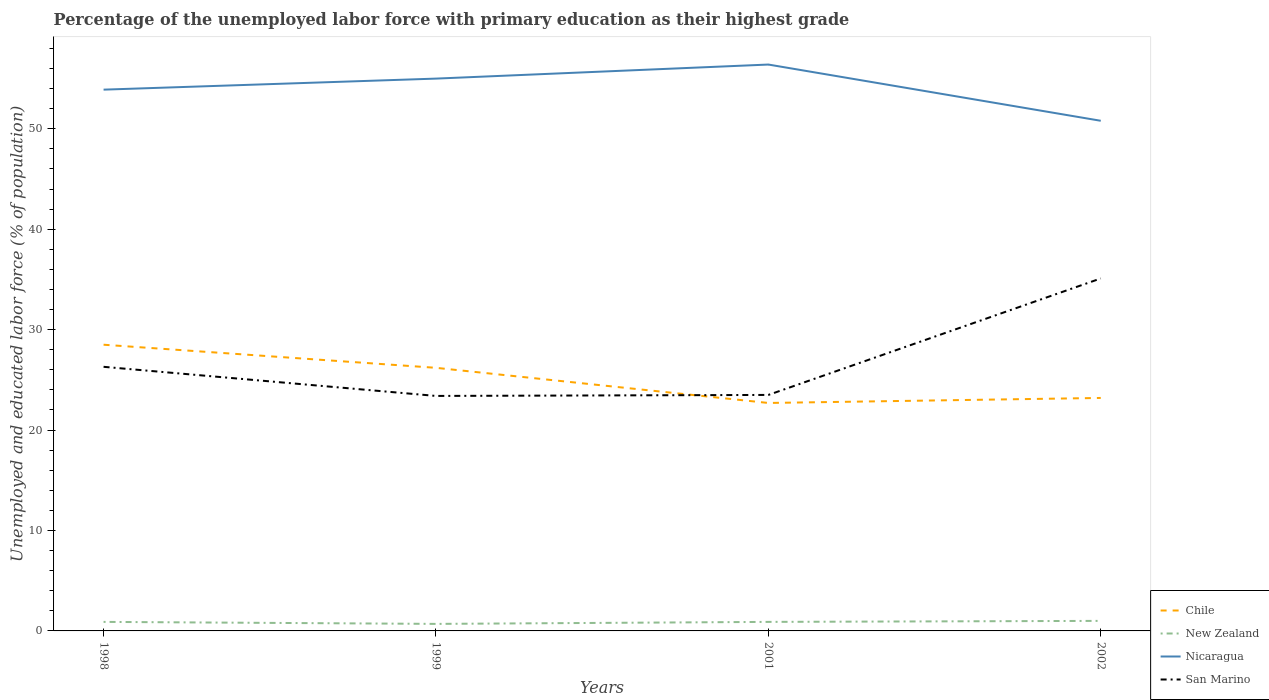Across all years, what is the maximum percentage of the unemployed labor force with primary education in Nicaragua?
Provide a succinct answer. 50.8. What is the total percentage of the unemployed labor force with primary education in Nicaragua in the graph?
Make the answer very short. 5.6. What is the difference between the highest and the second highest percentage of the unemployed labor force with primary education in Chile?
Give a very brief answer. 5.8. How many years are there in the graph?
Provide a short and direct response. 4. How many legend labels are there?
Your answer should be compact. 4. What is the title of the graph?
Offer a very short reply. Percentage of the unemployed labor force with primary education as their highest grade. Does "Bosnia and Herzegovina" appear as one of the legend labels in the graph?
Offer a terse response. No. What is the label or title of the X-axis?
Your answer should be compact. Years. What is the label or title of the Y-axis?
Keep it short and to the point. Unemployed and educated labor force (% of population). What is the Unemployed and educated labor force (% of population) of New Zealand in 1998?
Your answer should be compact. 0.9. What is the Unemployed and educated labor force (% of population) of Nicaragua in 1998?
Make the answer very short. 53.9. What is the Unemployed and educated labor force (% of population) of San Marino in 1998?
Offer a very short reply. 26.3. What is the Unemployed and educated labor force (% of population) of Chile in 1999?
Your answer should be very brief. 26.2. What is the Unemployed and educated labor force (% of population) in New Zealand in 1999?
Offer a very short reply. 0.7. What is the Unemployed and educated labor force (% of population) of San Marino in 1999?
Provide a short and direct response. 23.4. What is the Unemployed and educated labor force (% of population) in Chile in 2001?
Your response must be concise. 22.7. What is the Unemployed and educated labor force (% of population) of New Zealand in 2001?
Keep it short and to the point. 0.9. What is the Unemployed and educated labor force (% of population) in Nicaragua in 2001?
Keep it short and to the point. 56.4. What is the Unemployed and educated labor force (% of population) of San Marino in 2001?
Make the answer very short. 23.5. What is the Unemployed and educated labor force (% of population) in Chile in 2002?
Your response must be concise. 23.2. What is the Unemployed and educated labor force (% of population) in Nicaragua in 2002?
Provide a succinct answer. 50.8. What is the Unemployed and educated labor force (% of population) in San Marino in 2002?
Provide a succinct answer. 35.1. Across all years, what is the maximum Unemployed and educated labor force (% of population) in Chile?
Give a very brief answer. 28.5. Across all years, what is the maximum Unemployed and educated labor force (% of population) in New Zealand?
Provide a short and direct response. 1. Across all years, what is the maximum Unemployed and educated labor force (% of population) in Nicaragua?
Offer a terse response. 56.4. Across all years, what is the maximum Unemployed and educated labor force (% of population) in San Marino?
Ensure brevity in your answer.  35.1. Across all years, what is the minimum Unemployed and educated labor force (% of population) in Chile?
Your response must be concise. 22.7. Across all years, what is the minimum Unemployed and educated labor force (% of population) of New Zealand?
Offer a very short reply. 0.7. Across all years, what is the minimum Unemployed and educated labor force (% of population) of Nicaragua?
Offer a terse response. 50.8. Across all years, what is the minimum Unemployed and educated labor force (% of population) in San Marino?
Ensure brevity in your answer.  23.4. What is the total Unemployed and educated labor force (% of population) in Chile in the graph?
Offer a very short reply. 100.6. What is the total Unemployed and educated labor force (% of population) of Nicaragua in the graph?
Offer a terse response. 216.1. What is the total Unemployed and educated labor force (% of population) in San Marino in the graph?
Provide a short and direct response. 108.3. What is the difference between the Unemployed and educated labor force (% of population) of Chile in 1998 and that in 1999?
Make the answer very short. 2.3. What is the difference between the Unemployed and educated labor force (% of population) of San Marino in 1998 and that in 1999?
Your answer should be compact. 2.9. What is the difference between the Unemployed and educated labor force (% of population) in Nicaragua in 1998 and that in 2001?
Provide a short and direct response. -2.5. What is the difference between the Unemployed and educated labor force (% of population) of New Zealand in 1998 and that in 2002?
Your answer should be compact. -0.1. What is the difference between the Unemployed and educated labor force (% of population) of Nicaragua in 1998 and that in 2002?
Offer a very short reply. 3.1. What is the difference between the Unemployed and educated labor force (% of population) of San Marino in 1998 and that in 2002?
Your answer should be very brief. -8.8. What is the difference between the Unemployed and educated labor force (% of population) of New Zealand in 1999 and that in 2001?
Offer a terse response. -0.2. What is the difference between the Unemployed and educated labor force (% of population) of San Marino in 1999 and that in 2001?
Provide a short and direct response. -0.1. What is the difference between the Unemployed and educated labor force (% of population) of Chile in 1999 and that in 2002?
Give a very brief answer. 3. What is the difference between the Unemployed and educated labor force (% of population) of Nicaragua in 1999 and that in 2002?
Provide a short and direct response. 4.2. What is the difference between the Unemployed and educated labor force (% of population) of Chile in 2001 and that in 2002?
Your answer should be very brief. -0.5. What is the difference between the Unemployed and educated labor force (% of population) of New Zealand in 2001 and that in 2002?
Keep it short and to the point. -0.1. What is the difference between the Unemployed and educated labor force (% of population) of Chile in 1998 and the Unemployed and educated labor force (% of population) of New Zealand in 1999?
Provide a short and direct response. 27.8. What is the difference between the Unemployed and educated labor force (% of population) in Chile in 1998 and the Unemployed and educated labor force (% of population) in Nicaragua in 1999?
Your answer should be very brief. -26.5. What is the difference between the Unemployed and educated labor force (% of population) of Chile in 1998 and the Unemployed and educated labor force (% of population) of San Marino in 1999?
Provide a short and direct response. 5.1. What is the difference between the Unemployed and educated labor force (% of population) of New Zealand in 1998 and the Unemployed and educated labor force (% of population) of Nicaragua in 1999?
Ensure brevity in your answer.  -54.1. What is the difference between the Unemployed and educated labor force (% of population) in New Zealand in 1998 and the Unemployed and educated labor force (% of population) in San Marino in 1999?
Make the answer very short. -22.5. What is the difference between the Unemployed and educated labor force (% of population) in Nicaragua in 1998 and the Unemployed and educated labor force (% of population) in San Marino in 1999?
Give a very brief answer. 30.5. What is the difference between the Unemployed and educated labor force (% of population) of Chile in 1998 and the Unemployed and educated labor force (% of population) of New Zealand in 2001?
Keep it short and to the point. 27.6. What is the difference between the Unemployed and educated labor force (% of population) of Chile in 1998 and the Unemployed and educated labor force (% of population) of Nicaragua in 2001?
Provide a succinct answer. -27.9. What is the difference between the Unemployed and educated labor force (% of population) of Chile in 1998 and the Unemployed and educated labor force (% of population) of San Marino in 2001?
Offer a very short reply. 5. What is the difference between the Unemployed and educated labor force (% of population) in New Zealand in 1998 and the Unemployed and educated labor force (% of population) in Nicaragua in 2001?
Keep it short and to the point. -55.5. What is the difference between the Unemployed and educated labor force (% of population) of New Zealand in 1998 and the Unemployed and educated labor force (% of population) of San Marino in 2001?
Offer a very short reply. -22.6. What is the difference between the Unemployed and educated labor force (% of population) in Nicaragua in 1998 and the Unemployed and educated labor force (% of population) in San Marino in 2001?
Ensure brevity in your answer.  30.4. What is the difference between the Unemployed and educated labor force (% of population) of Chile in 1998 and the Unemployed and educated labor force (% of population) of Nicaragua in 2002?
Your answer should be compact. -22.3. What is the difference between the Unemployed and educated labor force (% of population) in New Zealand in 1998 and the Unemployed and educated labor force (% of population) in Nicaragua in 2002?
Your answer should be very brief. -49.9. What is the difference between the Unemployed and educated labor force (% of population) in New Zealand in 1998 and the Unemployed and educated labor force (% of population) in San Marino in 2002?
Offer a very short reply. -34.2. What is the difference between the Unemployed and educated labor force (% of population) in Nicaragua in 1998 and the Unemployed and educated labor force (% of population) in San Marino in 2002?
Your answer should be compact. 18.8. What is the difference between the Unemployed and educated labor force (% of population) in Chile in 1999 and the Unemployed and educated labor force (% of population) in New Zealand in 2001?
Keep it short and to the point. 25.3. What is the difference between the Unemployed and educated labor force (% of population) of Chile in 1999 and the Unemployed and educated labor force (% of population) of Nicaragua in 2001?
Ensure brevity in your answer.  -30.2. What is the difference between the Unemployed and educated labor force (% of population) of New Zealand in 1999 and the Unemployed and educated labor force (% of population) of Nicaragua in 2001?
Provide a succinct answer. -55.7. What is the difference between the Unemployed and educated labor force (% of population) of New Zealand in 1999 and the Unemployed and educated labor force (% of population) of San Marino in 2001?
Give a very brief answer. -22.8. What is the difference between the Unemployed and educated labor force (% of population) of Nicaragua in 1999 and the Unemployed and educated labor force (% of population) of San Marino in 2001?
Your response must be concise. 31.5. What is the difference between the Unemployed and educated labor force (% of population) in Chile in 1999 and the Unemployed and educated labor force (% of population) in New Zealand in 2002?
Your answer should be very brief. 25.2. What is the difference between the Unemployed and educated labor force (% of population) of Chile in 1999 and the Unemployed and educated labor force (% of population) of Nicaragua in 2002?
Provide a short and direct response. -24.6. What is the difference between the Unemployed and educated labor force (% of population) in Chile in 1999 and the Unemployed and educated labor force (% of population) in San Marino in 2002?
Offer a very short reply. -8.9. What is the difference between the Unemployed and educated labor force (% of population) in New Zealand in 1999 and the Unemployed and educated labor force (% of population) in Nicaragua in 2002?
Your answer should be very brief. -50.1. What is the difference between the Unemployed and educated labor force (% of population) in New Zealand in 1999 and the Unemployed and educated labor force (% of population) in San Marino in 2002?
Provide a succinct answer. -34.4. What is the difference between the Unemployed and educated labor force (% of population) in Nicaragua in 1999 and the Unemployed and educated labor force (% of population) in San Marino in 2002?
Your response must be concise. 19.9. What is the difference between the Unemployed and educated labor force (% of population) of Chile in 2001 and the Unemployed and educated labor force (% of population) of New Zealand in 2002?
Provide a short and direct response. 21.7. What is the difference between the Unemployed and educated labor force (% of population) in Chile in 2001 and the Unemployed and educated labor force (% of population) in Nicaragua in 2002?
Your answer should be very brief. -28.1. What is the difference between the Unemployed and educated labor force (% of population) in Chile in 2001 and the Unemployed and educated labor force (% of population) in San Marino in 2002?
Offer a very short reply. -12.4. What is the difference between the Unemployed and educated labor force (% of population) in New Zealand in 2001 and the Unemployed and educated labor force (% of population) in Nicaragua in 2002?
Your response must be concise. -49.9. What is the difference between the Unemployed and educated labor force (% of population) of New Zealand in 2001 and the Unemployed and educated labor force (% of population) of San Marino in 2002?
Your answer should be compact. -34.2. What is the difference between the Unemployed and educated labor force (% of population) of Nicaragua in 2001 and the Unemployed and educated labor force (% of population) of San Marino in 2002?
Your answer should be very brief. 21.3. What is the average Unemployed and educated labor force (% of population) in Chile per year?
Offer a very short reply. 25.15. What is the average Unemployed and educated labor force (% of population) in New Zealand per year?
Give a very brief answer. 0.88. What is the average Unemployed and educated labor force (% of population) in Nicaragua per year?
Your answer should be compact. 54.02. What is the average Unemployed and educated labor force (% of population) of San Marino per year?
Give a very brief answer. 27.07. In the year 1998, what is the difference between the Unemployed and educated labor force (% of population) in Chile and Unemployed and educated labor force (% of population) in New Zealand?
Provide a short and direct response. 27.6. In the year 1998, what is the difference between the Unemployed and educated labor force (% of population) in Chile and Unemployed and educated labor force (% of population) in Nicaragua?
Offer a terse response. -25.4. In the year 1998, what is the difference between the Unemployed and educated labor force (% of population) of Chile and Unemployed and educated labor force (% of population) of San Marino?
Make the answer very short. 2.2. In the year 1998, what is the difference between the Unemployed and educated labor force (% of population) of New Zealand and Unemployed and educated labor force (% of population) of Nicaragua?
Ensure brevity in your answer.  -53. In the year 1998, what is the difference between the Unemployed and educated labor force (% of population) of New Zealand and Unemployed and educated labor force (% of population) of San Marino?
Keep it short and to the point. -25.4. In the year 1998, what is the difference between the Unemployed and educated labor force (% of population) of Nicaragua and Unemployed and educated labor force (% of population) of San Marino?
Provide a succinct answer. 27.6. In the year 1999, what is the difference between the Unemployed and educated labor force (% of population) of Chile and Unemployed and educated labor force (% of population) of New Zealand?
Offer a terse response. 25.5. In the year 1999, what is the difference between the Unemployed and educated labor force (% of population) in Chile and Unemployed and educated labor force (% of population) in Nicaragua?
Ensure brevity in your answer.  -28.8. In the year 1999, what is the difference between the Unemployed and educated labor force (% of population) of Chile and Unemployed and educated labor force (% of population) of San Marino?
Ensure brevity in your answer.  2.8. In the year 1999, what is the difference between the Unemployed and educated labor force (% of population) in New Zealand and Unemployed and educated labor force (% of population) in Nicaragua?
Provide a short and direct response. -54.3. In the year 1999, what is the difference between the Unemployed and educated labor force (% of population) of New Zealand and Unemployed and educated labor force (% of population) of San Marino?
Keep it short and to the point. -22.7. In the year 1999, what is the difference between the Unemployed and educated labor force (% of population) of Nicaragua and Unemployed and educated labor force (% of population) of San Marino?
Provide a succinct answer. 31.6. In the year 2001, what is the difference between the Unemployed and educated labor force (% of population) of Chile and Unemployed and educated labor force (% of population) of New Zealand?
Your response must be concise. 21.8. In the year 2001, what is the difference between the Unemployed and educated labor force (% of population) in Chile and Unemployed and educated labor force (% of population) in Nicaragua?
Your response must be concise. -33.7. In the year 2001, what is the difference between the Unemployed and educated labor force (% of population) in Chile and Unemployed and educated labor force (% of population) in San Marino?
Your answer should be compact. -0.8. In the year 2001, what is the difference between the Unemployed and educated labor force (% of population) of New Zealand and Unemployed and educated labor force (% of population) of Nicaragua?
Provide a succinct answer. -55.5. In the year 2001, what is the difference between the Unemployed and educated labor force (% of population) of New Zealand and Unemployed and educated labor force (% of population) of San Marino?
Ensure brevity in your answer.  -22.6. In the year 2001, what is the difference between the Unemployed and educated labor force (% of population) in Nicaragua and Unemployed and educated labor force (% of population) in San Marino?
Provide a succinct answer. 32.9. In the year 2002, what is the difference between the Unemployed and educated labor force (% of population) of Chile and Unemployed and educated labor force (% of population) of Nicaragua?
Make the answer very short. -27.6. In the year 2002, what is the difference between the Unemployed and educated labor force (% of population) in Chile and Unemployed and educated labor force (% of population) in San Marino?
Offer a very short reply. -11.9. In the year 2002, what is the difference between the Unemployed and educated labor force (% of population) in New Zealand and Unemployed and educated labor force (% of population) in Nicaragua?
Give a very brief answer. -49.8. In the year 2002, what is the difference between the Unemployed and educated labor force (% of population) of New Zealand and Unemployed and educated labor force (% of population) of San Marino?
Keep it short and to the point. -34.1. In the year 2002, what is the difference between the Unemployed and educated labor force (% of population) in Nicaragua and Unemployed and educated labor force (% of population) in San Marino?
Give a very brief answer. 15.7. What is the ratio of the Unemployed and educated labor force (% of population) in Chile in 1998 to that in 1999?
Keep it short and to the point. 1.09. What is the ratio of the Unemployed and educated labor force (% of population) of New Zealand in 1998 to that in 1999?
Offer a very short reply. 1.29. What is the ratio of the Unemployed and educated labor force (% of population) of Nicaragua in 1998 to that in 1999?
Your response must be concise. 0.98. What is the ratio of the Unemployed and educated labor force (% of population) of San Marino in 1998 to that in 1999?
Your answer should be compact. 1.12. What is the ratio of the Unemployed and educated labor force (% of population) in Chile in 1998 to that in 2001?
Offer a terse response. 1.26. What is the ratio of the Unemployed and educated labor force (% of population) of Nicaragua in 1998 to that in 2001?
Give a very brief answer. 0.96. What is the ratio of the Unemployed and educated labor force (% of population) in San Marino in 1998 to that in 2001?
Ensure brevity in your answer.  1.12. What is the ratio of the Unemployed and educated labor force (% of population) of Chile in 1998 to that in 2002?
Provide a short and direct response. 1.23. What is the ratio of the Unemployed and educated labor force (% of population) in New Zealand in 1998 to that in 2002?
Your response must be concise. 0.9. What is the ratio of the Unemployed and educated labor force (% of population) in Nicaragua in 1998 to that in 2002?
Ensure brevity in your answer.  1.06. What is the ratio of the Unemployed and educated labor force (% of population) of San Marino in 1998 to that in 2002?
Provide a succinct answer. 0.75. What is the ratio of the Unemployed and educated labor force (% of population) in Chile in 1999 to that in 2001?
Your answer should be compact. 1.15. What is the ratio of the Unemployed and educated labor force (% of population) in New Zealand in 1999 to that in 2001?
Keep it short and to the point. 0.78. What is the ratio of the Unemployed and educated labor force (% of population) of Nicaragua in 1999 to that in 2001?
Your response must be concise. 0.98. What is the ratio of the Unemployed and educated labor force (% of population) of Chile in 1999 to that in 2002?
Give a very brief answer. 1.13. What is the ratio of the Unemployed and educated labor force (% of population) in Nicaragua in 1999 to that in 2002?
Keep it short and to the point. 1.08. What is the ratio of the Unemployed and educated labor force (% of population) in San Marino in 1999 to that in 2002?
Ensure brevity in your answer.  0.67. What is the ratio of the Unemployed and educated labor force (% of population) of Chile in 2001 to that in 2002?
Provide a short and direct response. 0.98. What is the ratio of the Unemployed and educated labor force (% of population) in New Zealand in 2001 to that in 2002?
Your answer should be very brief. 0.9. What is the ratio of the Unemployed and educated labor force (% of population) of Nicaragua in 2001 to that in 2002?
Ensure brevity in your answer.  1.11. What is the ratio of the Unemployed and educated labor force (% of population) of San Marino in 2001 to that in 2002?
Provide a succinct answer. 0.67. What is the difference between the highest and the second highest Unemployed and educated labor force (% of population) in Chile?
Your answer should be compact. 2.3. What is the difference between the highest and the lowest Unemployed and educated labor force (% of population) in Chile?
Make the answer very short. 5.8. What is the difference between the highest and the lowest Unemployed and educated labor force (% of population) of New Zealand?
Your response must be concise. 0.3. What is the difference between the highest and the lowest Unemployed and educated labor force (% of population) of San Marino?
Your answer should be very brief. 11.7. 